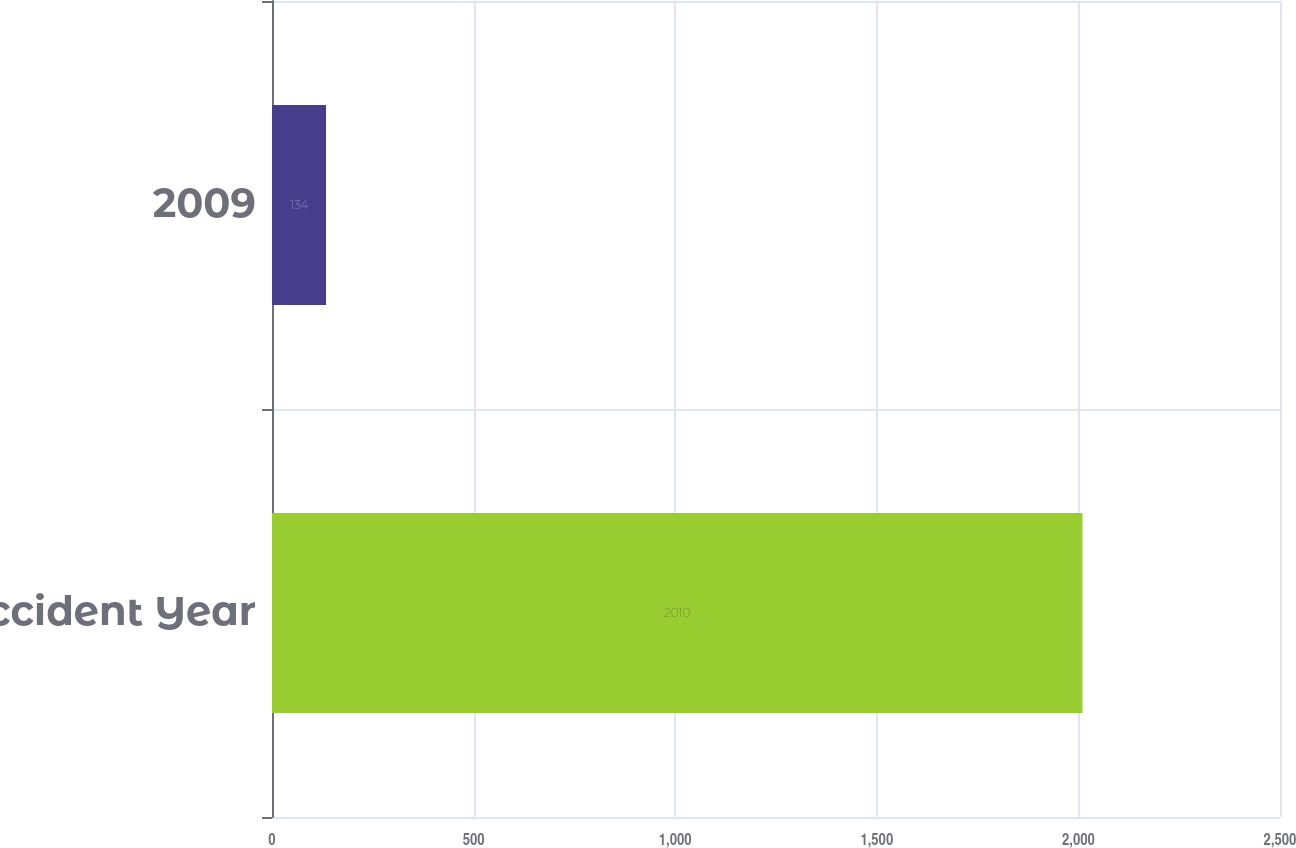Convert chart to OTSL. <chart><loc_0><loc_0><loc_500><loc_500><bar_chart><fcel>Accident Year<fcel>2009<nl><fcel>2010<fcel>134<nl></chart> 